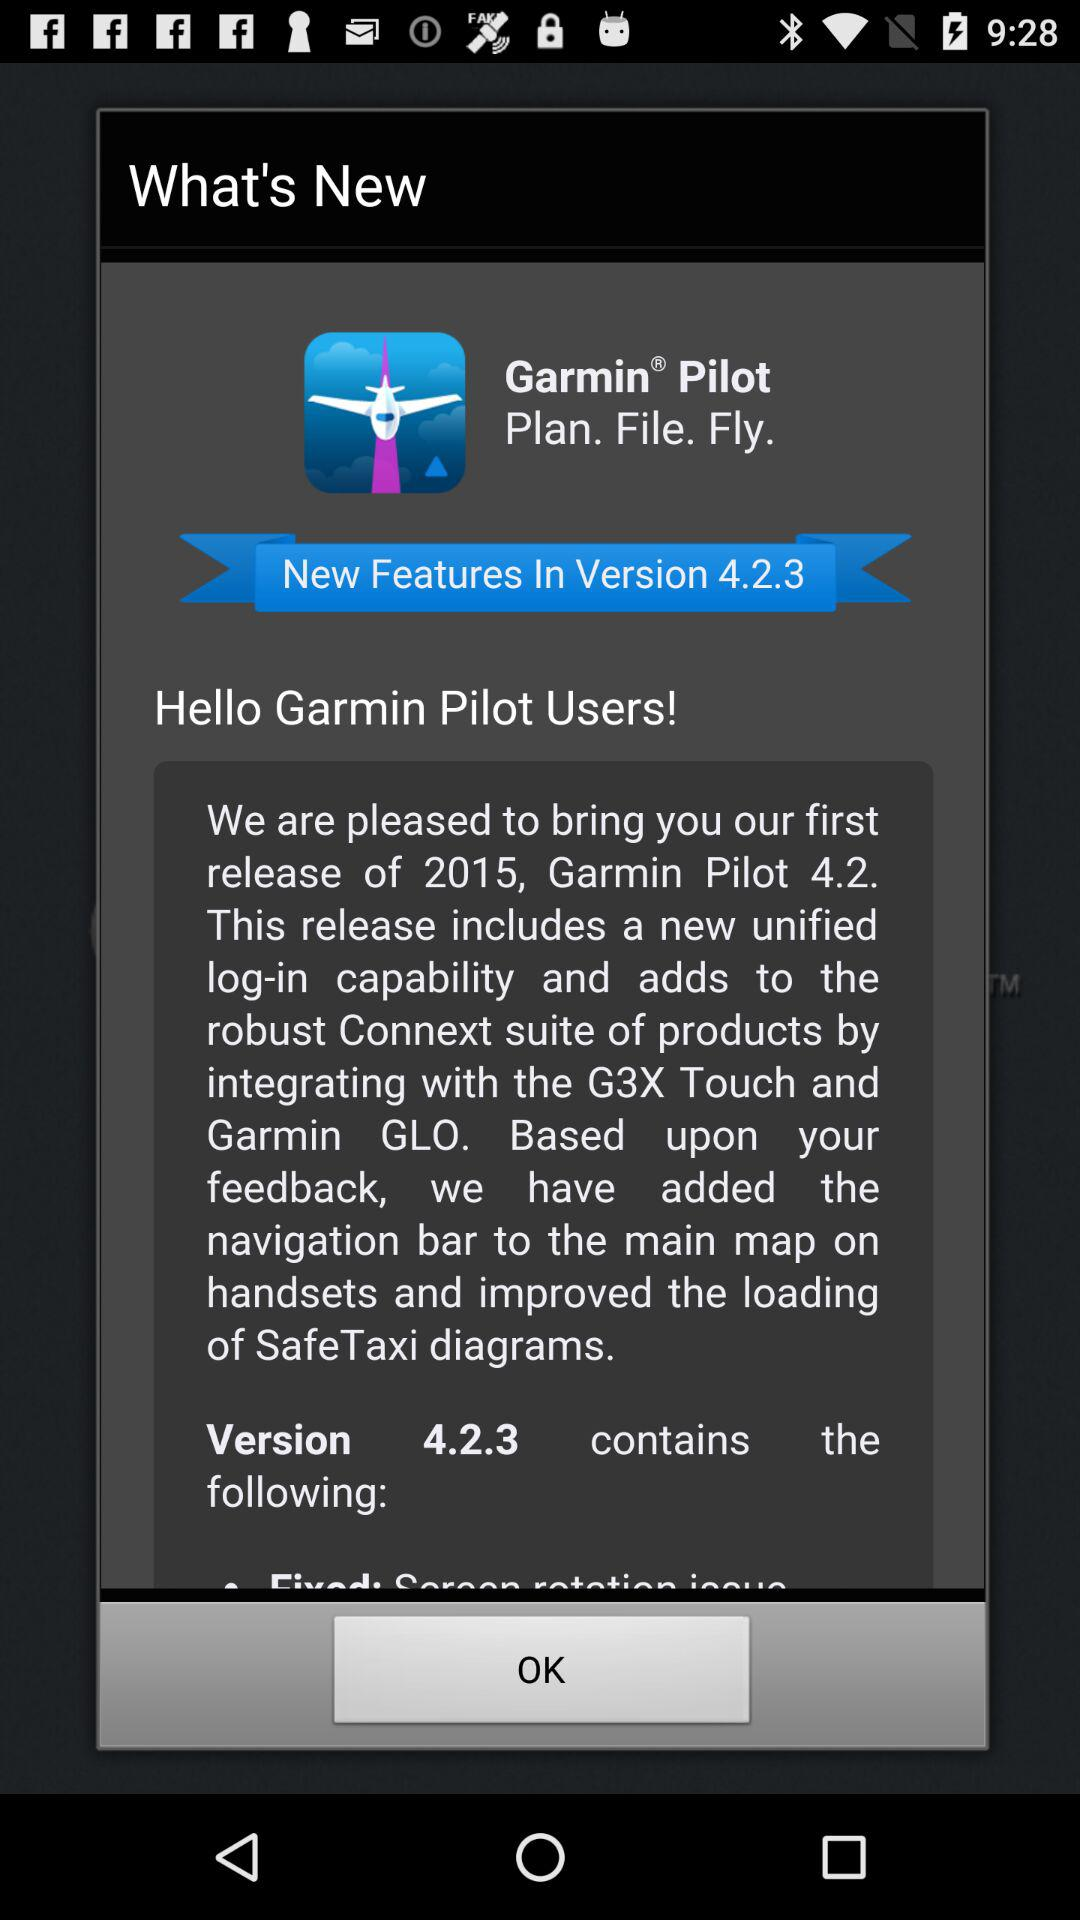What is the version of the app? The version of the app is 4.2.3. 